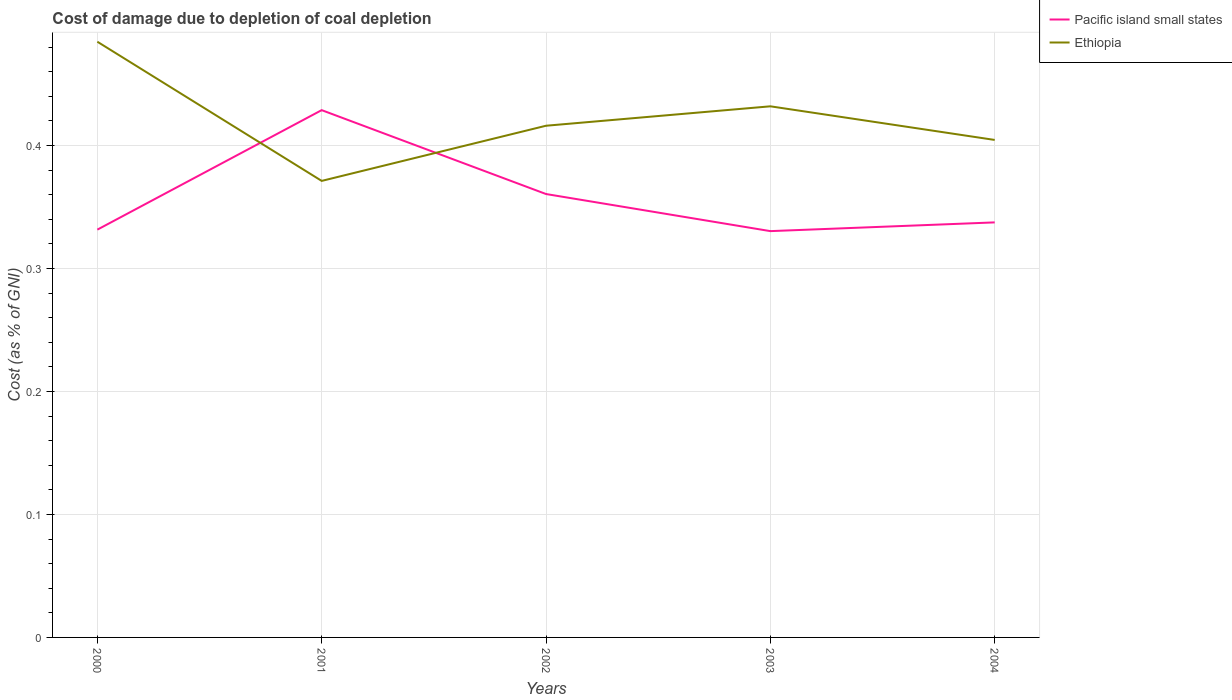How many different coloured lines are there?
Give a very brief answer. 2. Is the number of lines equal to the number of legend labels?
Provide a succinct answer. Yes. Across all years, what is the maximum cost of damage caused due to coal depletion in Pacific island small states?
Give a very brief answer. 0.33. What is the total cost of damage caused due to coal depletion in Ethiopia in the graph?
Provide a succinct answer. 0.07. What is the difference between the highest and the second highest cost of damage caused due to coal depletion in Ethiopia?
Your response must be concise. 0.11. What is the difference between the highest and the lowest cost of damage caused due to coal depletion in Ethiopia?
Ensure brevity in your answer.  2. What is the difference between two consecutive major ticks on the Y-axis?
Give a very brief answer. 0.1. Does the graph contain grids?
Provide a short and direct response. Yes. Where does the legend appear in the graph?
Offer a terse response. Top right. How many legend labels are there?
Provide a short and direct response. 2. What is the title of the graph?
Ensure brevity in your answer.  Cost of damage due to depletion of coal depletion. Does "Kazakhstan" appear as one of the legend labels in the graph?
Keep it short and to the point. No. What is the label or title of the X-axis?
Provide a short and direct response. Years. What is the label or title of the Y-axis?
Your answer should be compact. Cost (as % of GNI). What is the Cost (as % of GNI) of Pacific island small states in 2000?
Ensure brevity in your answer.  0.33. What is the Cost (as % of GNI) of Ethiopia in 2000?
Ensure brevity in your answer.  0.48. What is the Cost (as % of GNI) of Pacific island small states in 2001?
Provide a succinct answer. 0.43. What is the Cost (as % of GNI) in Ethiopia in 2001?
Your answer should be compact. 0.37. What is the Cost (as % of GNI) of Pacific island small states in 2002?
Offer a terse response. 0.36. What is the Cost (as % of GNI) in Ethiopia in 2002?
Ensure brevity in your answer.  0.42. What is the Cost (as % of GNI) in Pacific island small states in 2003?
Your answer should be compact. 0.33. What is the Cost (as % of GNI) of Ethiopia in 2003?
Offer a very short reply. 0.43. What is the Cost (as % of GNI) of Pacific island small states in 2004?
Your response must be concise. 0.34. What is the Cost (as % of GNI) of Ethiopia in 2004?
Keep it short and to the point. 0.4. Across all years, what is the maximum Cost (as % of GNI) in Pacific island small states?
Your response must be concise. 0.43. Across all years, what is the maximum Cost (as % of GNI) of Ethiopia?
Give a very brief answer. 0.48. Across all years, what is the minimum Cost (as % of GNI) of Pacific island small states?
Offer a very short reply. 0.33. Across all years, what is the minimum Cost (as % of GNI) in Ethiopia?
Ensure brevity in your answer.  0.37. What is the total Cost (as % of GNI) in Pacific island small states in the graph?
Offer a very short reply. 1.79. What is the total Cost (as % of GNI) in Ethiopia in the graph?
Your response must be concise. 2.11. What is the difference between the Cost (as % of GNI) in Pacific island small states in 2000 and that in 2001?
Keep it short and to the point. -0.1. What is the difference between the Cost (as % of GNI) in Ethiopia in 2000 and that in 2001?
Offer a terse response. 0.11. What is the difference between the Cost (as % of GNI) in Pacific island small states in 2000 and that in 2002?
Your answer should be very brief. -0.03. What is the difference between the Cost (as % of GNI) in Ethiopia in 2000 and that in 2002?
Offer a terse response. 0.07. What is the difference between the Cost (as % of GNI) in Pacific island small states in 2000 and that in 2003?
Your response must be concise. 0. What is the difference between the Cost (as % of GNI) of Ethiopia in 2000 and that in 2003?
Provide a short and direct response. 0.05. What is the difference between the Cost (as % of GNI) in Pacific island small states in 2000 and that in 2004?
Offer a terse response. -0.01. What is the difference between the Cost (as % of GNI) of Ethiopia in 2000 and that in 2004?
Offer a terse response. 0.08. What is the difference between the Cost (as % of GNI) in Pacific island small states in 2001 and that in 2002?
Make the answer very short. 0.07. What is the difference between the Cost (as % of GNI) in Ethiopia in 2001 and that in 2002?
Make the answer very short. -0.04. What is the difference between the Cost (as % of GNI) in Pacific island small states in 2001 and that in 2003?
Keep it short and to the point. 0.1. What is the difference between the Cost (as % of GNI) of Ethiopia in 2001 and that in 2003?
Your answer should be very brief. -0.06. What is the difference between the Cost (as % of GNI) in Pacific island small states in 2001 and that in 2004?
Your answer should be very brief. 0.09. What is the difference between the Cost (as % of GNI) of Ethiopia in 2001 and that in 2004?
Offer a terse response. -0.03. What is the difference between the Cost (as % of GNI) in Pacific island small states in 2002 and that in 2003?
Keep it short and to the point. 0.03. What is the difference between the Cost (as % of GNI) in Ethiopia in 2002 and that in 2003?
Make the answer very short. -0.02. What is the difference between the Cost (as % of GNI) of Pacific island small states in 2002 and that in 2004?
Your answer should be very brief. 0.02. What is the difference between the Cost (as % of GNI) in Ethiopia in 2002 and that in 2004?
Your response must be concise. 0.01. What is the difference between the Cost (as % of GNI) in Pacific island small states in 2003 and that in 2004?
Your response must be concise. -0.01. What is the difference between the Cost (as % of GNI) in Ethiopia in 2003 and that in 2004?
Offer a terse response. 0.03. What is the difference between the Cost (as % of GNI) in Pacific island small states in 2000 and the Cost (as % of GNI) in Ethiopia in 2001?
Keep it short and to the point. -0.04. What is the difference between the Cost (as % of GNI) of Pacific island small states in 2000 and the Cost (as % of GNI) of Ethiopia in 2002?
Offer a very short reply. -0.08. What is the difference between the Cost (as % of GNI) of Pacific island small states in 2000 and the Cost (as % of GNI) of Ethiopia in 2003?
Your answer should be very brief. -0.1. What is the difference between the Cost (as % of GNI) of Pacific island small states in 2000 and the Cost (as % of GNI) of Ethiopia in 2004?
Offer a terse response. -0.07. What is the difference between the Cost (as % of GNI) in Pacific island small states in 2001 and the Cost (as % of GNI) in Ethiopia in 2002?
Your response must be concise. 0.01. What is the difference between the Cost (as % of GNI) in Pacific island small states in 2001 and the Cost (as % of GNI) in Ethiopia in 2003?
Ensure brevity in your answer.  -0. What is the difference between the Cost (as % of GNI) of Pacific island small states in 2001 and the Cost (as % of GNI) of Ethiopia in 2004?
Offer a terse response. 0.02. What is the difference between the Cost (as % of GNI) in Pacific island small states in 2002 and the Cost (as % of GNI) in Ethiopia in 2003?
Ensure brevity in your answer.  -0.07. What is the difference between the Cost (as % of GNI) in Pacific island small states in 2002 and the Cost (as % of GNI) in Ethiopia in 2004?
Provide a succinct answer. -0.04. What is the difference between the Cost (as % of GNI) of Pacific island small states in 2003 and the Cost (as % of GNI) of Ethiopia in 2004?
Provide a short and direct response. -0.07. What is the average Cost (as % of GNI) of Pacific island small states per year?
Offer a terse response. 0.36. What is the average Cost (as % of GNI) in Ethiopia per year?
Give a very brief answer. 0.42. In the year 2000, what is the difference between the Cost (as % of GNI) in Pacific island small states and Cost (as % of GNI) in Ethiopia?
Provide a succinct answer. -0.15. In the year 2001, what is the difference between the Cost (as % of GNI) in Pacific island small states and Cost (as % of GNI) in Ethiopia?
Offer a terse response. 0.06. In the year 2002, what is the difference between the Cost (as % of GNI) in Pacific island small states and Cost (as % of GNI) in Ethiopia?
Make the answer very short. -0.06. In the year 2003, what is the difference between the Cost (as % of GNI) in Pacific island small states and Cost (as % of GNI) in Ethiopia?
Your answer should be compact. -0.1. In the year 2004, what is the difference between the Cost (as % of GNI) of Pacific island small states and Cost (as % of GNI) of Ethiopia?
Offer a terse response. -0.07. What is the ratio of the Cost (as % of GNI) in Pacific island small states in 2000 to that in 2001?
Make the answer very short. 0.77. What is the ratio of the Cost (as % of GNI) in Ethiopia in 2000 to that in 2001?
Ensure brevity in your answer.  1.3. What is the ratio of the Cost (as % of GNI) in Pacific island small states in 2000 to that in 2002?
Ensure brevity in your answer.  0.92. What is the ratio of the Cost (as % of GNI) of Ethiopia in 2000 to that in 2002?
Provide a succinct answer. 1.16. What is the ratio of the Cost (as % of GNI) in Pacific island small states in 2000 to that in 2003?
Your response must be concise. 1. What is the ratio of the Cost (as % of GNI) in Ethiopia in 2000 to that in 2003?
Provide a short and direct response. 1.12. What is the ratio of the Cost (as % of GNI) of Pacific island small states in 2000 to that in 2004?
Keep it short and to the point. 0.98. What is the ratio of the Cost (as % of GNI) in Ethiopia in 2000 to that in 2004?
Your response must be concise. 1.2. What is the ratio of the Cost (as % of GNI) in Pacific island small states in 2001 to that in 2002?
Your response must be concise. 1.19. What is the ratio of the Cost (as % of GNI) in Ethiopia in 2001 to that in 2002?
Make the answer very short. 0.89. What is the ratio of the Cost (as % of GNI) in Pacific island small states in 2001 to that in 2003?
Offer a terse response. 1.3. What is the ratio of the Cost (as % of GNI) of Ethiopia in 2001 to that in 2003?
Keep it short and to the point. 0.86. What is the ratio of the Cost (as % of GNI) of Pacific island small states in 2001 to that in 2004?
Your answer should be very brief. 1.27. What is the ratio of the Cost (as % of GNI) in Ethiopia in 2001 to that in 2004?
Make the answer very short. 0.92. What is the ratio of the Cost (as % of GNI) in Pacific island small states in 2002 to that in 2003?
Keep it short and to the point. 1.09. What is the ratio of the Cost (as % of GNI) of Ethiopia in 2002 to that in 2003?
Ensure brevity in your answer.  0.96. What is the ratio of the Cost (as % of GNI) in Pacific island small states in 2002 to that in 2004?
Ensure brevity in your answer.  1.07. What is the ratio of the Cost (as % of GNI) in Ethiopia in 2002 to that in 2004?
Your answer should be compact. 1.03. What is the ratio of the Cost (as % of GNI) of Ethiopia in 2003 to that in 2004?
Make the answer very short. 1.07. What is the difference between the highest and the second highest Cost (as % of GNI) of Pacific island small states?
Your answer should be compact. 0.07. What is the difference between the highest and the second highest Cost (as % of GNI) in Ethiopia?
Make the answer very short. 0.05. What is the difference between the highest and the lowest Cost (as % of GNI) of Pacific island small states?
Make the answer very short. 0.1. What is the difference between the highest and the lowest Cost (as % of GNI) of Ethiopia?
Your answer should be compact. 0.11. 